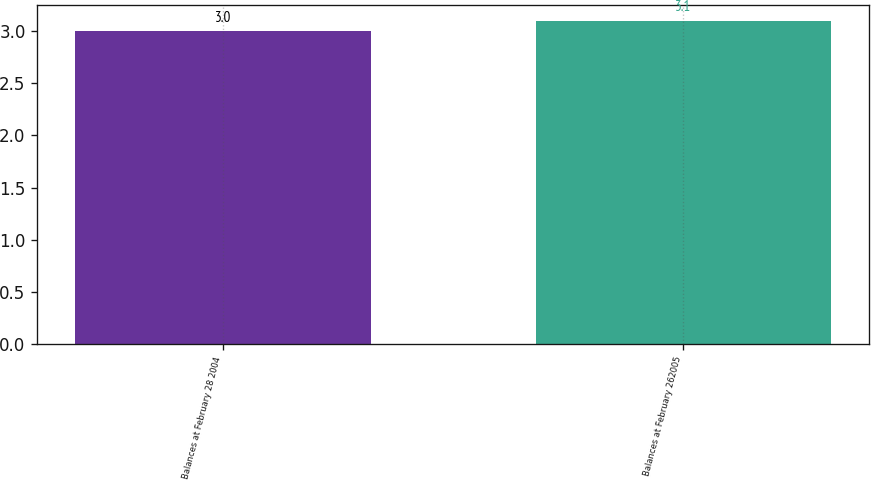Convert chart to OTSL. <chart><loc_0><loc_0><loc_500><loc_500><bar_chart><fcel>Balances at February 28 2004<fcel>Balances at February 262005<nl><fcel>3<fcel>3.1<nl></chart> 